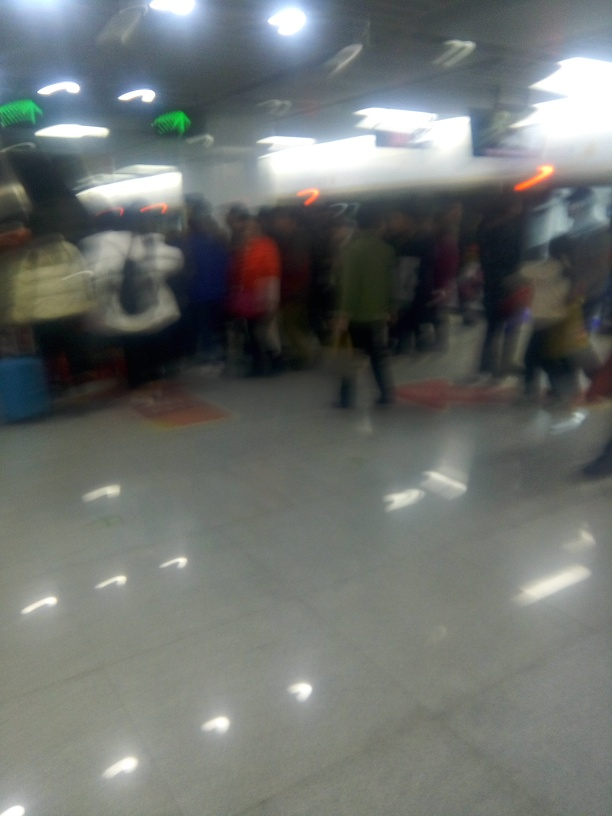What is the quality of this image? The image is of very poor quality due to significant blurring, likely from camera movement during capture or incorrect focus setting. It's not suitable for purposes that require detail, such as identifying individuals or reading signage. 